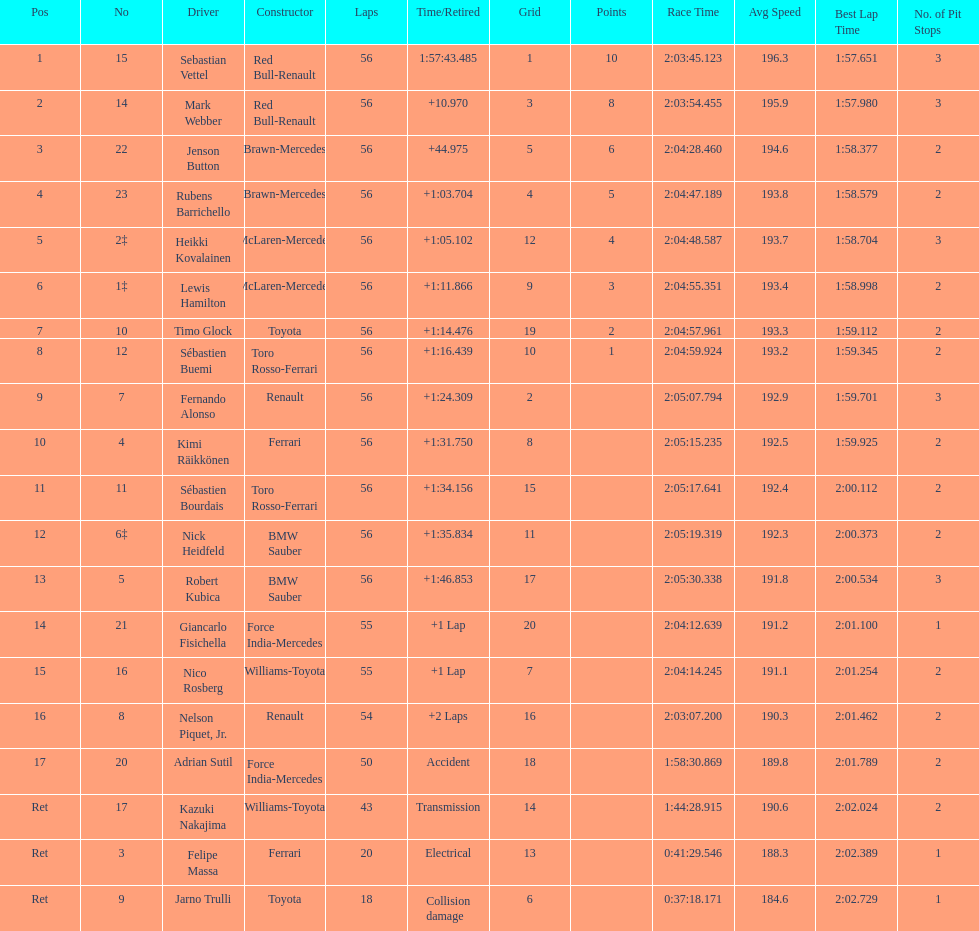What is the name of a driver that ferrari was not a constructor for? Sebastian Vettel. 